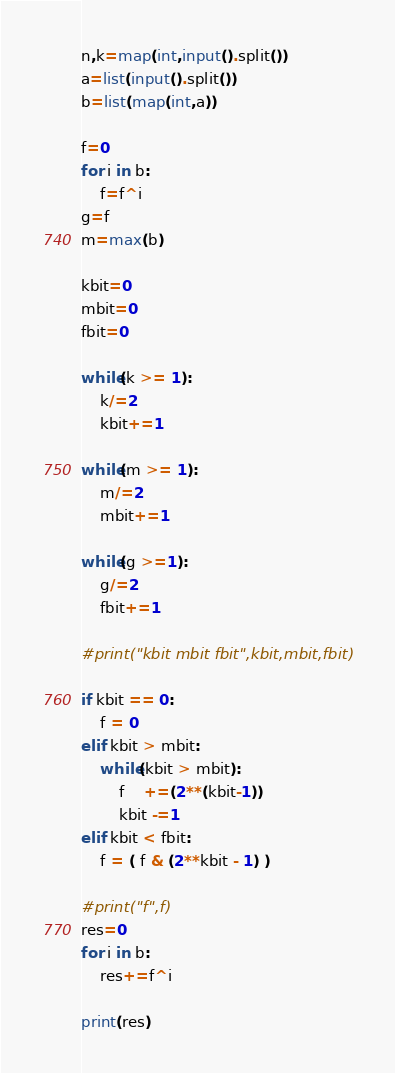<code> <loc_0><loc_0><loc_500><loc_500><_Python_>n,k=map(int,input().split())
a=list(input().split())
b=list(map(int,a))

f=0
for i in b:
    f=f^i
g=f  
m=max(b)

kbit=0
mbit=0
fbit=0

while(k >= 1):
    k/=2
    kbit+=1

while(m >= 1):
    m/=2
    mbit+=1

while(g >=1):
    g/=2
    fbit+=1

#print("kbit mbit fbit",kbit,mbit,fbit)

if kbit == 0:
    f = 0
elif kbit > mbit:
    while(kbit > mbit):
        f    +=(2**(kbit-1))
        kbit -=1
elif kbit < fbit:
    f = ( f & (2**kbit - 1) ) 

#print("f",f)
res=0
for i in b:
    res+=f^i

print(res)</code> 